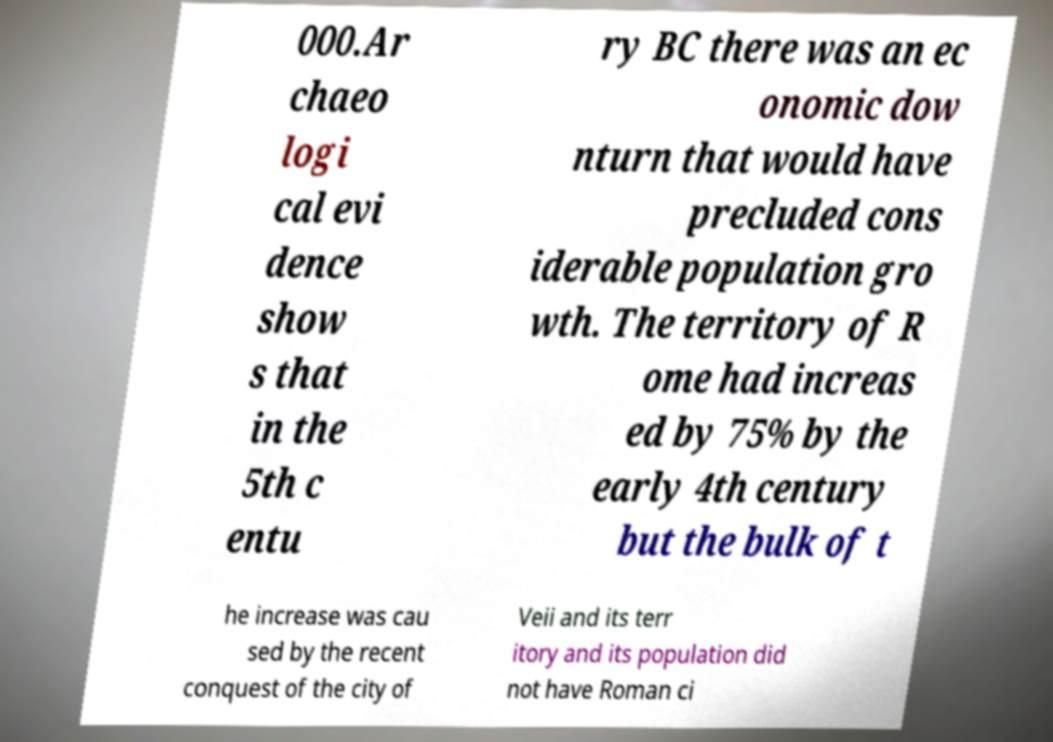What messages or text are displayed in this image? I need them in a readable, typed format. 000.Ar chaeo logi cal evi dence show s that in the 5th c entu ry BC there was an ec onomic dow nturn that would have precluded cons iderable population gro wth. The territory of R ome had increas ed by 75% by the early 4th century but the bulk of t he increase was cau sed by the recent conquest of the city of Veii and its terr itory and its population did not have Roman ci 